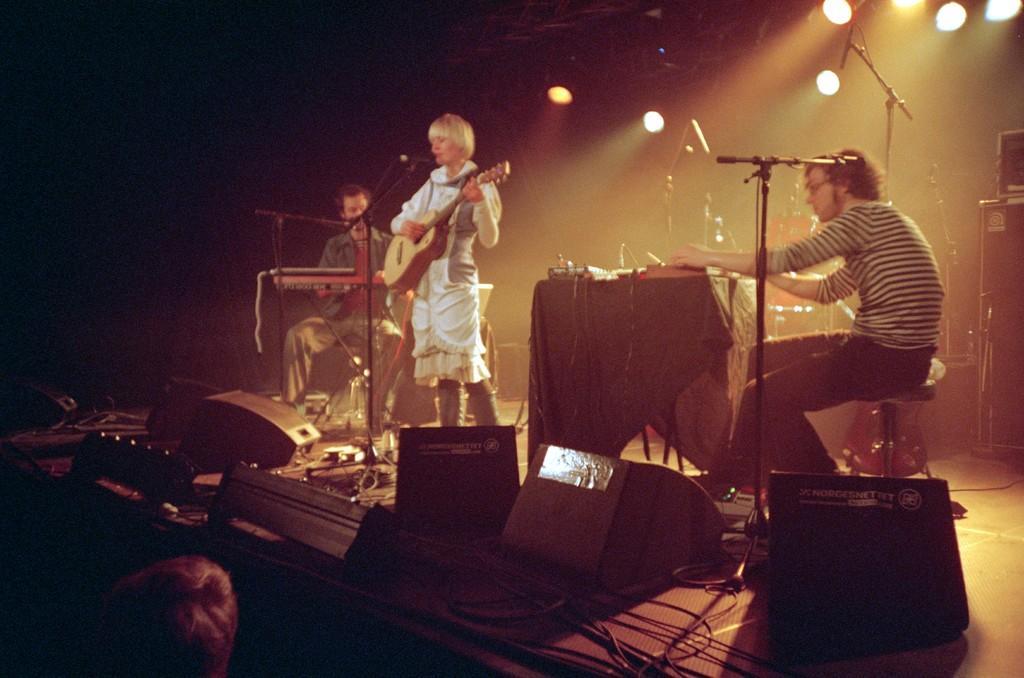Describe this image in one or two sentences. In the picture there is a woman playing guitar and singing on mic in the middle, on either sides of her man playing other music instrument, they are on stage and on ceiling there are lights. 